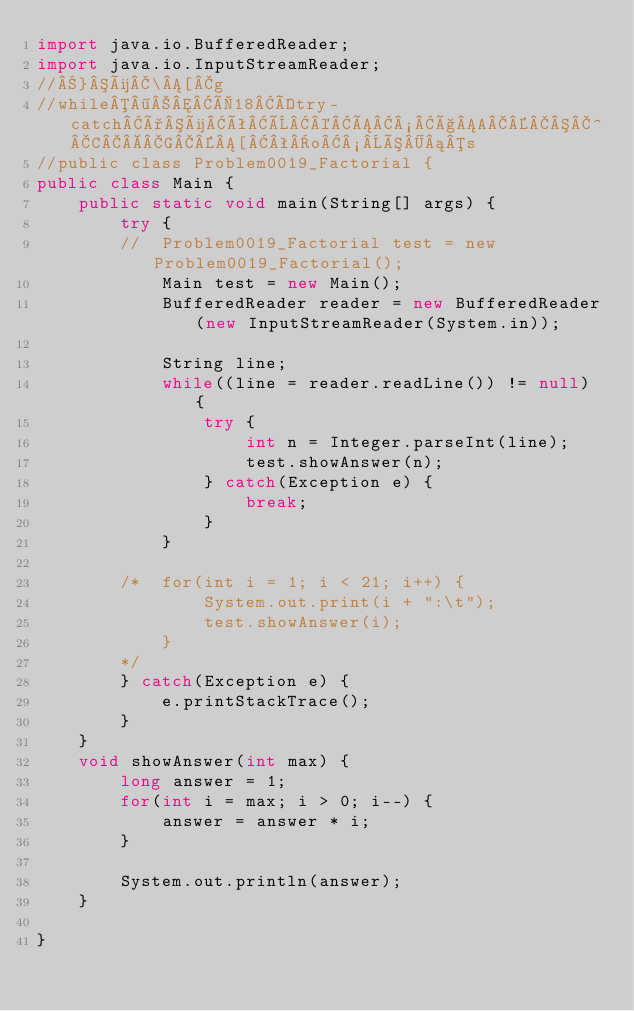<code> <loc_0><loc_0><loc_500><loc_500><_Java_>import java.io.BufferedReader;
import java.io.InputStreamReader;
//}ü\[g
//while¶Ì18Ítry-catchðüêÈ©Á½çA^CG[ªo½Ó¡s
//public class Problem0019_Factorial {
public class Main {
	public static void main(String[] args) {
		try {
		//	Problem0019_Factorial test = new Problem0019_Factorial();
			Main test = new Main();
			BufferedReader reader = new BufferedReader(new InputStreamReader(System.in));
			
			String line;
			while((line = reader.readLine()) != null) {
				try {
					int n = Integer.parseInt(line);
					test.showAnswer(n);
				} catch(Exception e) {
					break;
				}
			}
		
		/*	for(int i = 1; i < 21; i++) {
				System.out.print(i + ":\t");
				test.showAnswer(i);
			}
		*/
		} catch(Exception e) {
			e.printStackTrace();
		}
	}
	void showAnswer(int max) {
		long answer = 1;
		for(int i = max; i > 0; i--) {
			answer = answer * i;
		}
		
		System.out.println(answer);
	}

}</code> 